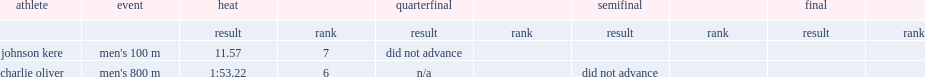In the solomon islands at the 1984 summer olympics, how many seconds did johnson kere spend in the heat? 11.57. 